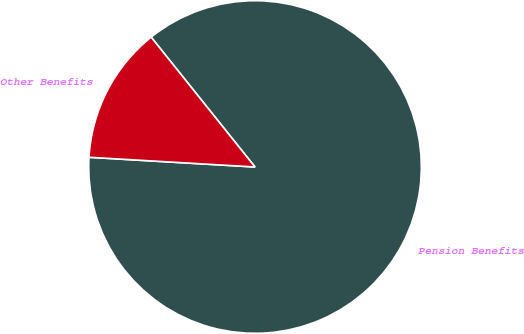Convert chart to OTSL. <chart><loc_0><loc_0><loc_500><loc_500><pie_chart><fcel>Pension Benefits<fcel>Other Benefits<nl><fcel>86.67%<fcel>13.33%<nl></chart> 